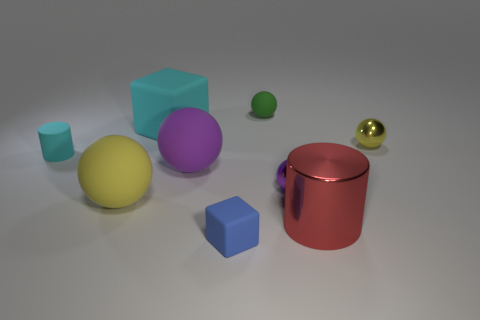What material is the big thing that is the same color as the small cylinder?
Make the answer very short. Rubber. There is a yellow ball left of the purple shiny object in front of the matte cube behind the metal cylinder; what is its size?
Provide a succinct answer. Large. How many gray objects are either metallic spheres or small metallic blocks?
Your response must be concise. 0. What is the shape of the big matte object in front of the shiny ball left of the large red cylinder?
Your response must be concise. Sphere. Do the cyan thing that is in front of the big cyan matte object and the metallic thing in front of the large yellow rubber object have the same size?
Make the answer very short. No. Is there a gray cylinder made of the same material as the tiny green ball?
Keep it short and to the point. No. What is the size of the matte thing that is the same color as the small cylinder?
Your response must be concise. Large. Is there a small thing to the right of the cyan object that is right of the yellow thing left of the blue cube?
Keep it short and to the point. Yes. There is a small yellow shiny thing; are there any big objects behind it?
Make the answer very short. Yes. How many small yellow shiny spheres are to the left of the cyan matte thing that is to the left of the big yellow matte sphere?
Your answer should be very brief. 0. 